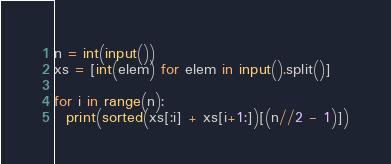Convert code to text. <code><loc_0><loc_0><loc_500><loc_500><_Python_>n = int(input())
xs = [int(elem) for elem in input().split()]

for i in range(n):
  print(sorted(xs[:i] + xs[i+1:])[(n//2 - 1)])</code> 